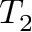Convert formula to latex. <formula><loc_0><loc_0><loc_500><loc_500>T _ { 2 }</formula> 